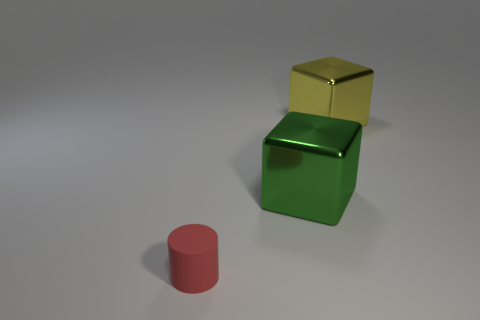Add 2 tiny cyan matte spheres. How many objects exist? 5 Subtract all cylinders. How many objects are left? 2 Subtract all big green cubes. Subtract all big green blocks. How many objects are left? 1 Add 3 shiny cubes. How many shiny cubes are left? 5 Add 3 small cylinders. How many small cylinders exist? 4 Subtract 0 blue cylinders. How many objects are left? 3 